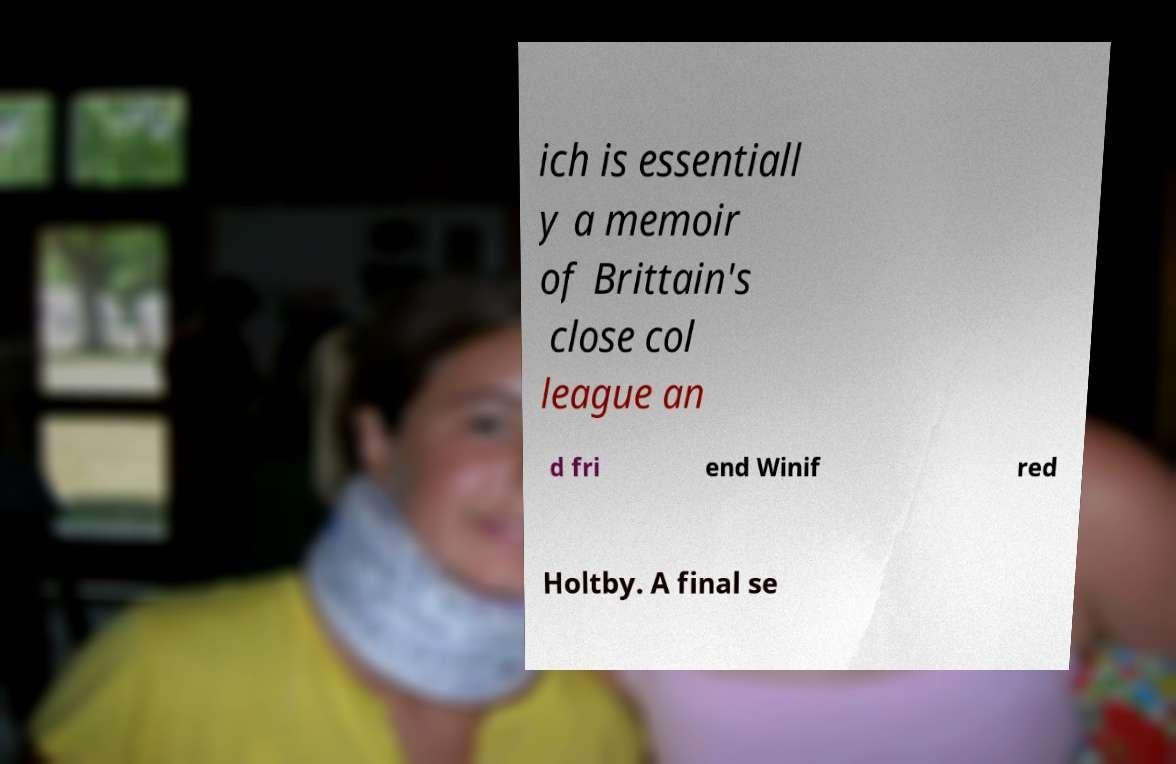Please identify and transcribe the text found in this image. ich is essentiall y a memoir of Brittain's close col league an d fri end Winif red Holtby. A final se 